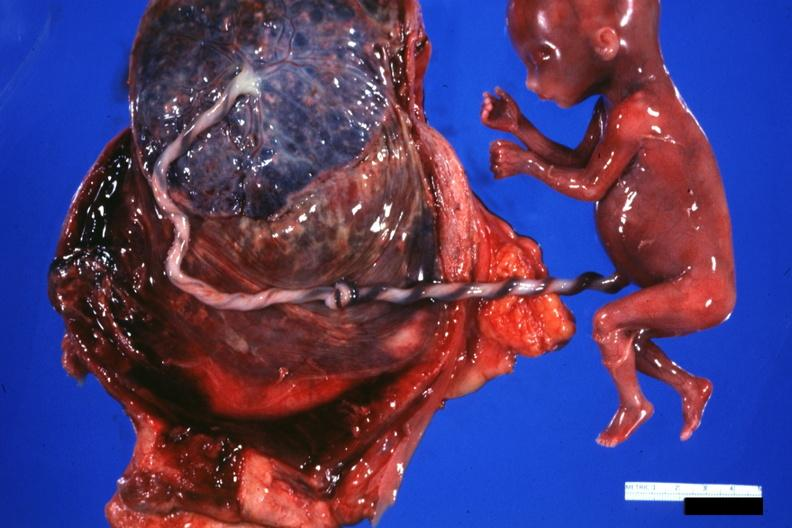what is present?
Answer the question using a single word or phrase. Female reproductive 